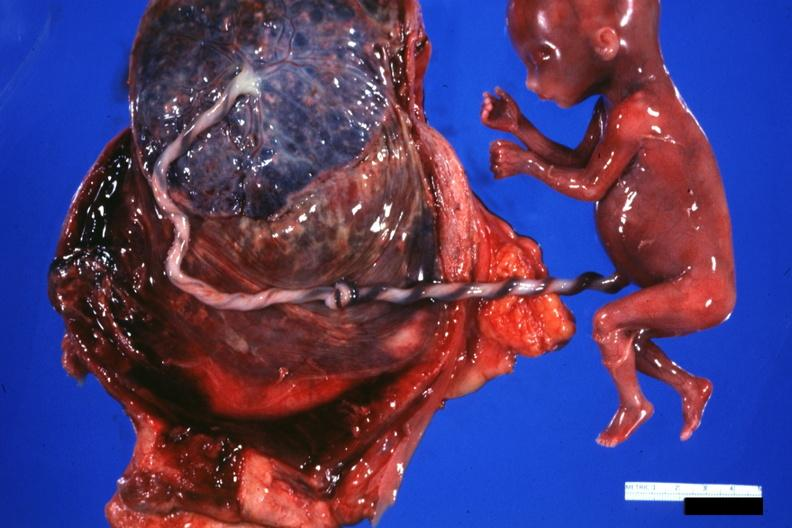what is present?
Answer the question using a single word or phrase. Female reproductive 